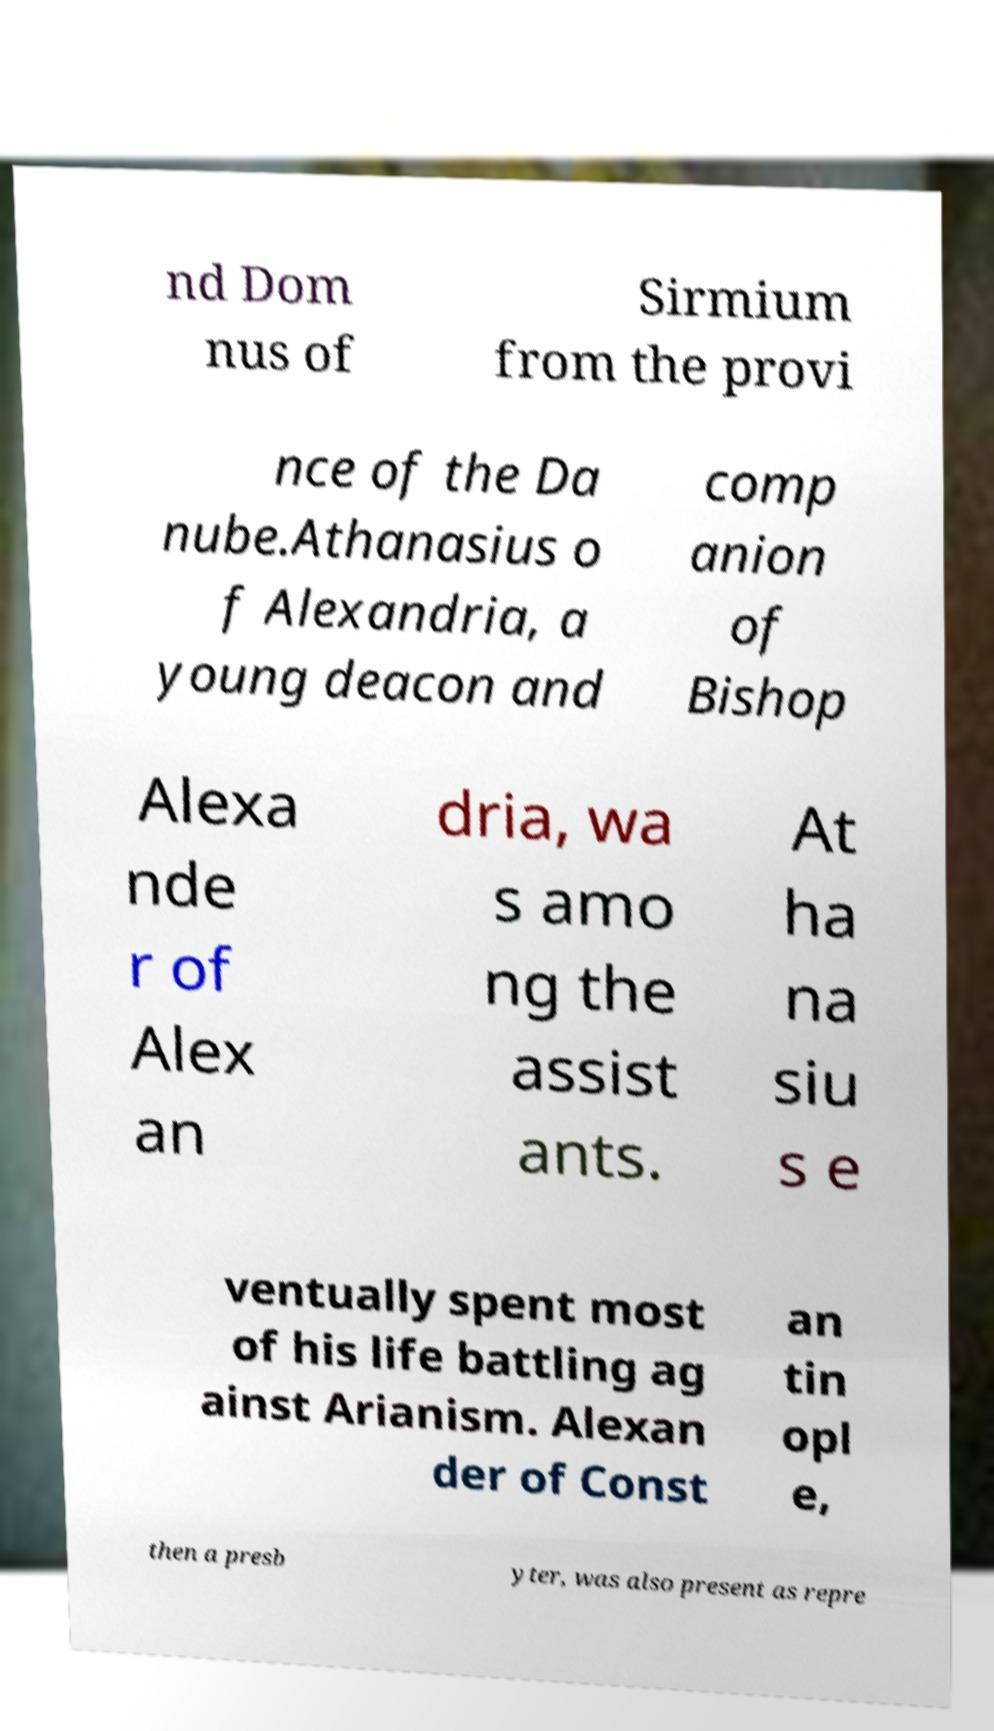Please read and relay the text visible in this image. What does it say? nd Dom nus of Sirmium from the provi nce of the Da nube.Athanasius o f Alexandria, a young deacon and comp anion of Bishop Alexa nde r of Alex an dria, wa s amo ng the assist ants. At ha na siu s e ventually spent most of his life battling ag ainst Arianism. Alexan der of Const an tin opl e, then a presb yter, was also present as repre 